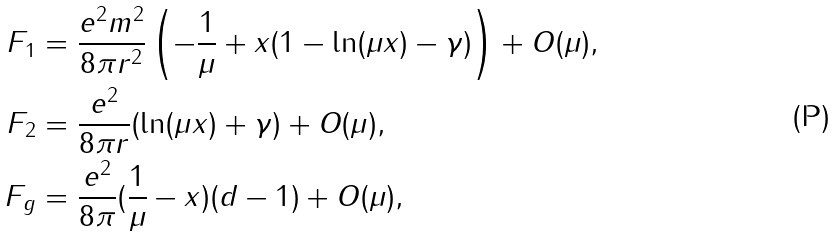<formula> <loc_0><loc_0><loc_500><loc_500>F _ { 1 } & = \frac { e ^ { 2 } m ^ { 2 } } { 8 \pi r ^ { 2 } } \left ( - \frac { 1 } { \mu } + x ( 1 - \ln ( \mu x ) - \gamma ) \right ) + O ( \mu ) , \\ F _ { 2 } & = \frac { e ^ { 2 } } { 8 \pi r } ( \ln ( \mu x ) + \gamma ) + O ( \mu ) , \\ F _ { g } & = \frac { e ^ { 2 } } { 8 \pi } ( \frac { 1 } { \mu } - x ) ( d - 1 ) + O ( \mu ) ,</formula> 